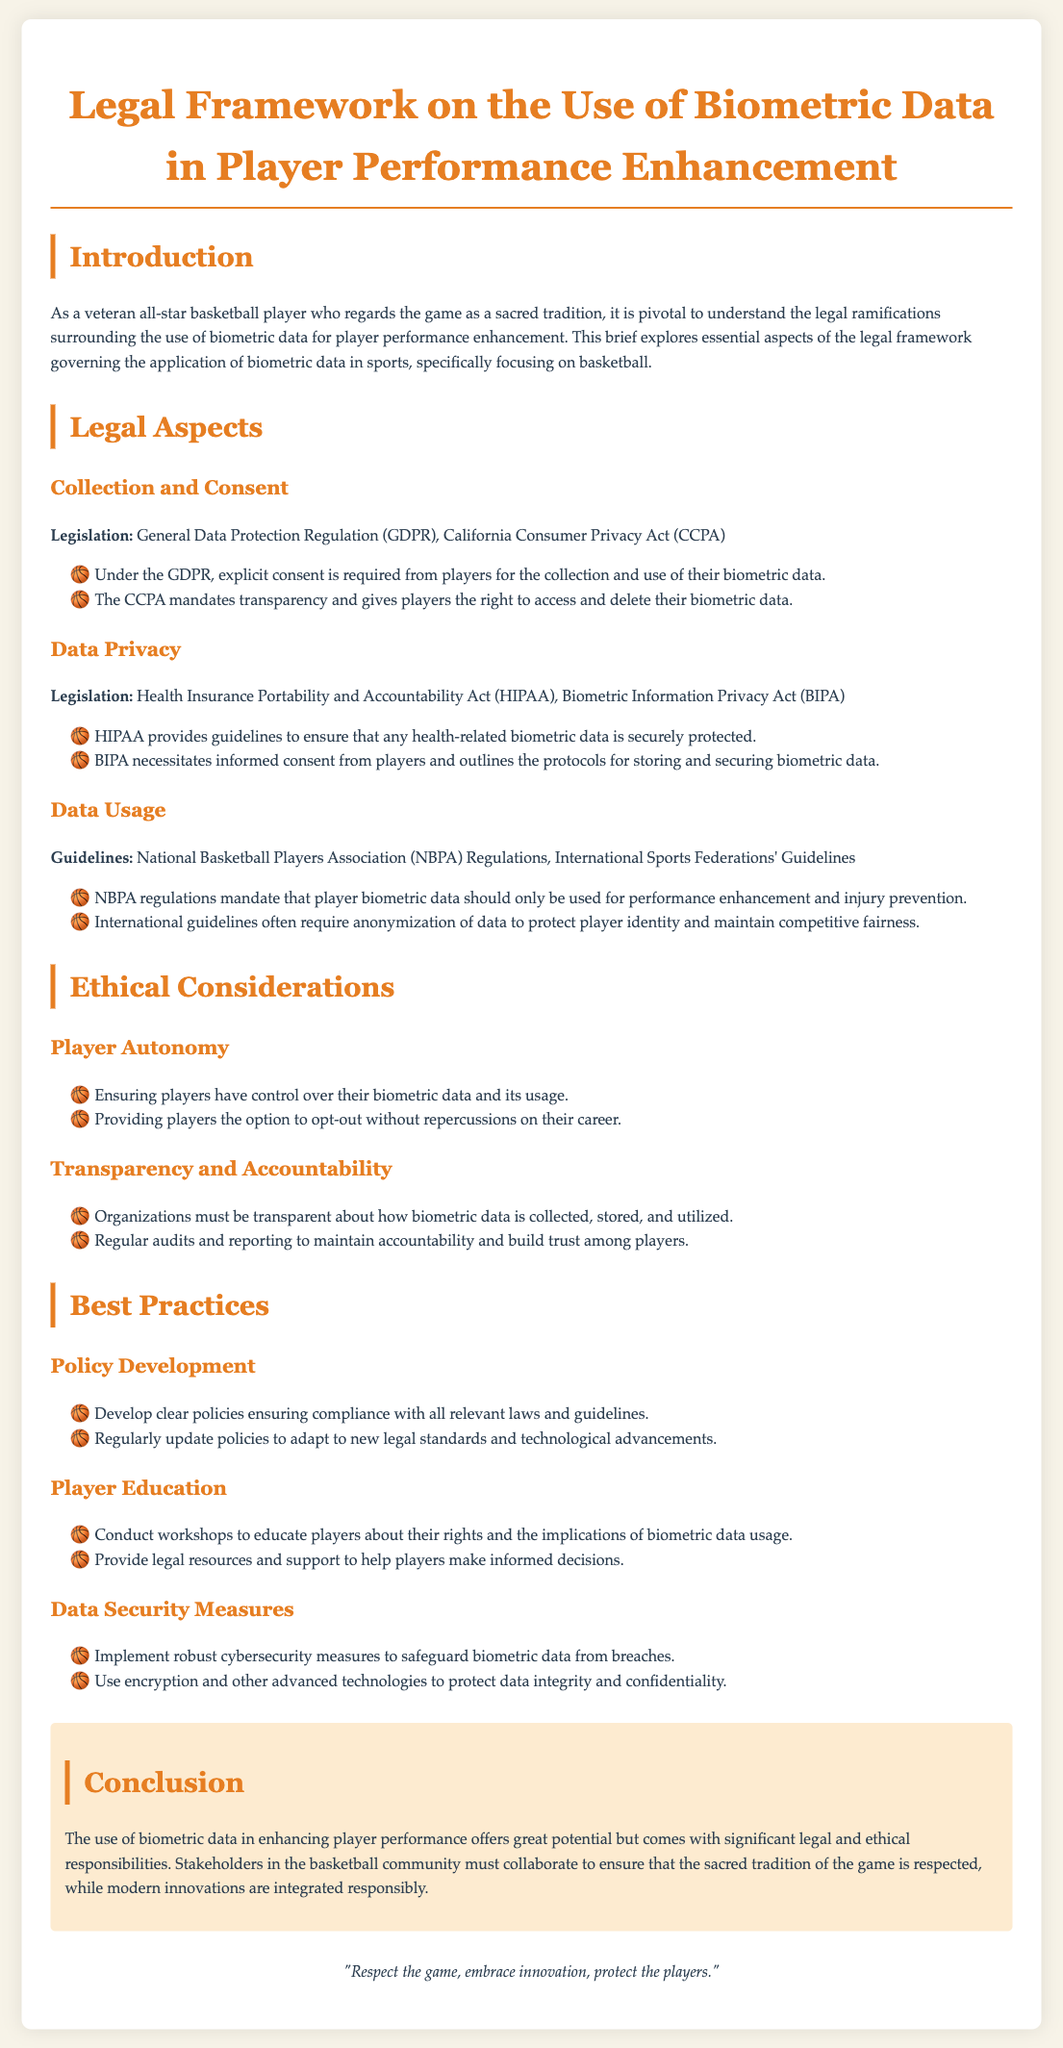What is the title of the document? The title is stated at the beginning of the document, summarizing its content.
Answer: Legal Framework on the Use of Biometric Data in Player Performance Enhancement Which regulation requires explicit consent for biometric data collection? The regulation that requires explicit consent is mentioned under "Collection and Consent" in the Legal Aspects section.
Answer: General Data Protection Regulation (GDPR) What does the CCPA mandate regarding players' biometric data? The CCPA's mandate is detailed in the same section and discusses rights concerning player data.
Answer: Transparency and access What is the primary purpose of using biometric data according to NBPA regulations? The primary purpose is outlined under "Data Usage" in the guide and indicates how the data should be used.
Answer: Performance enhancement and injury prevention Which act provides guidelines to protect health-related biometric data? This act is mentioned in the "Data Privacy" section of the document.
Answer: Health Insurance Portability and Accountability Act (HIPAA) What ethical consideration ensures players control their biometric data? This consideration is highlighted in the Ethical Considerations section, relating to player rights.
Answer: Player Autonomy What does BIPA require from players regarding their biometric data? BIPA's requirement is specified in the "Data Privacy" section that describes consent protocols.
Answer: Informed consent What does the document suggest regarding updating policies on biometric data? The recommendation for policy updates is found in the "Best Practices" section focusing on compliance.
Answer: Regularly update policies What is the concluding message of the document? The conclusion summarizes the main theme regarding balancing tradition and innovation.
Answer: Respect the game, embrace innovation, protect the players 